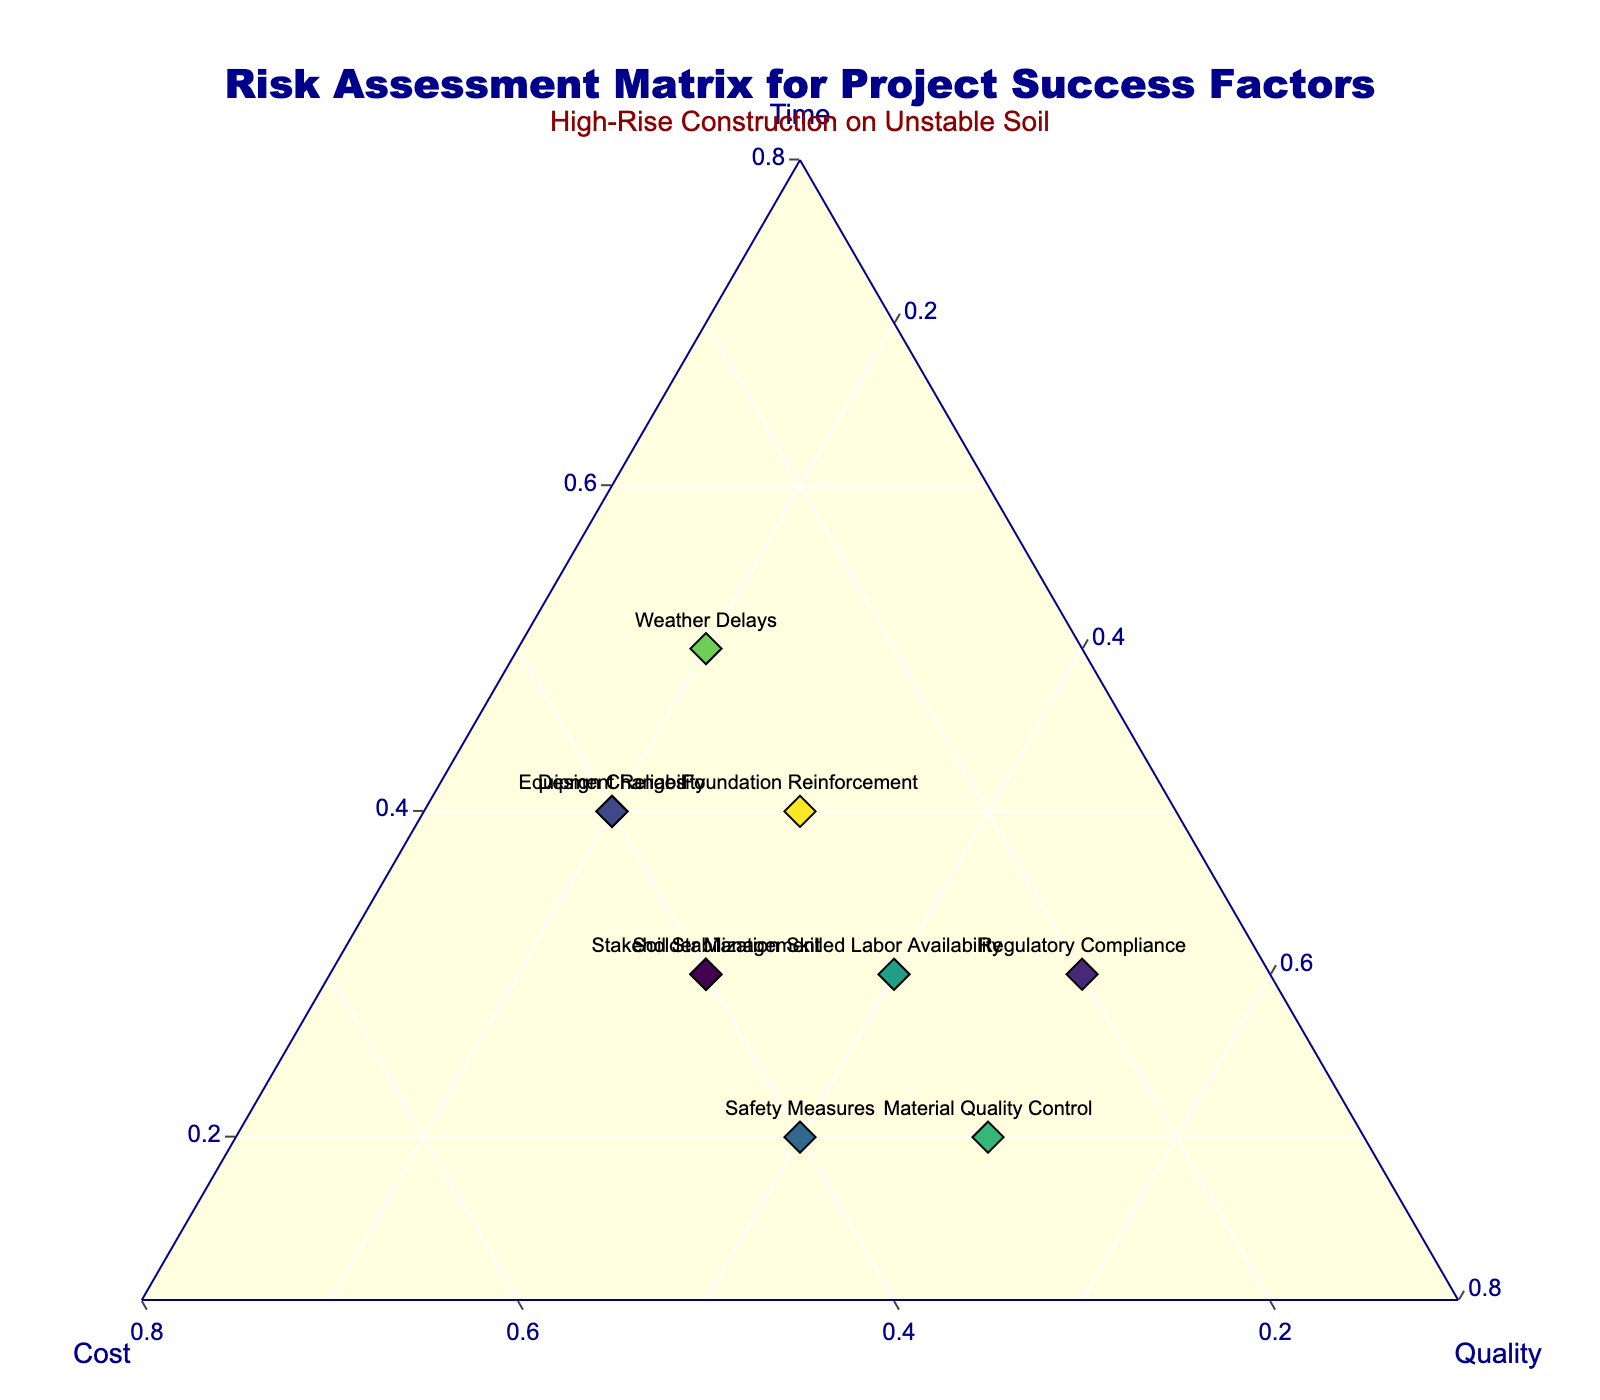What is the title of the figure? The title of the figure is prominently displayed at the top.
Answer: Risk Assessment Matrix for Project Success Factors What does the ternary plot assess? The text at the top of the plot explains that the ternary plot assesses the risk factors affecting time, cost, and quality for constructing a high-rise on unstable soil.
Answer: Risk factors affecting time, cost, and quality Which factor is identified as having the highest impact on quality? By looking at the ternary plot, the factor with the highest value along the quality axis (closest to the quality vertex) is "Material Quality Control" with a value of 0.5.
Answer: Material Quality Control How many factors have an equal distribution among time, cost, and quality? Observing the plot, factors whose points are positioned equally distant from all three vertices indicate an equal distribution. None of the factors have their points exactly centrally positioned, denoting equal distribution.
Answer: 0 Compare the impact on time between "Foundation Reinforcement" and "Equipment Reliability". Which has a higher value? On the ternary plot, "Foundation Reinforcement" is closer to the time vertex with a value of 0.4, and "Equipment Reliability" also has a value of 0.4. Therefore, both have equal values.
Answer: Equal (0.4) Which two factors have identical values for time, cost, and quality? Checking the ternary plot and the table, the factors "Equipment Reliability" and "Design Changes" both have values (0.4, 0.4, 0.2) for time, cost, and quality.
Answer: Equipment Reliability and Design Changes Identify the factor closest to having consistent values across time, cost, and quality. Reviewing the values from the plot, "Skilled Labor Availability" has values (0.3, 0.3, 0.4), making it the factor with values most nearly consistent across all three elements.
Answer: Skilled Labor Availability Which factor has the lowest impact on cost? From the ternary plot and reference table, "Regulatory Compliance" has the lowest cost value of 0.2.
Answer: Regulatory Compliance Between "Safety Measures" and "Soil Stabilization," which has a higher impact on cost? Referring to the ternary plot, "Safety Measures" has a cost impact value of 0.4, while "Soil Stabilization" has a value of 0.4 as well, so they are equal.
Answer: Equal (0.4) 